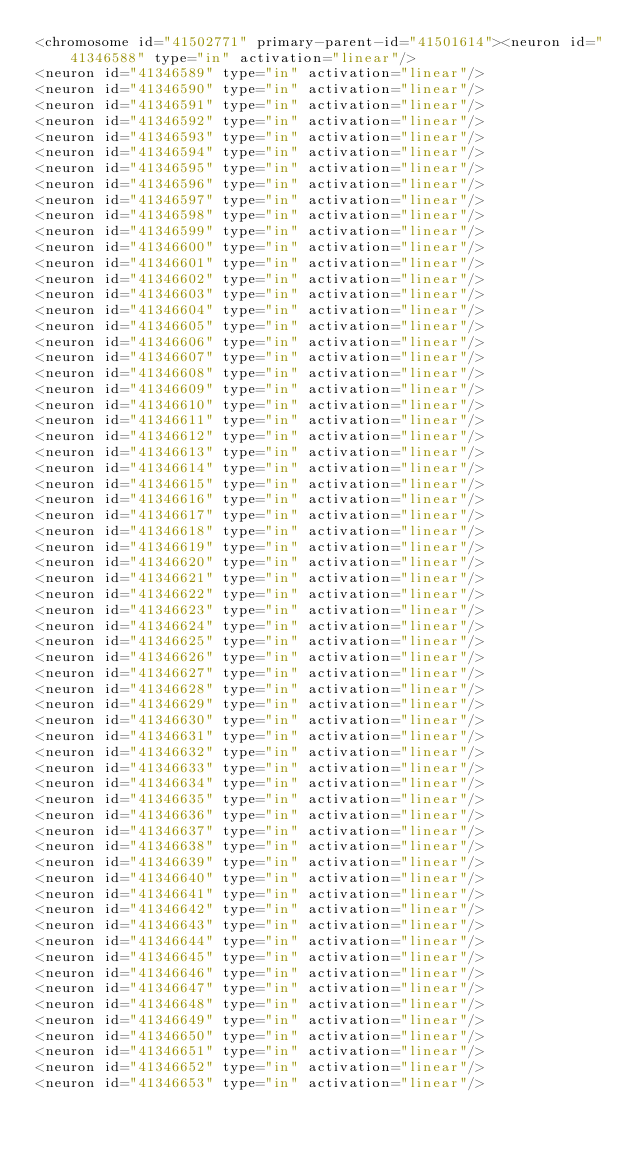<code> <loc_0><loc_0><loc_500><loc_500><_XML_><chromosome id="41502771" primary-parent-id="41501614"><neuron id="41346588" type="in" activation="linear"/>
<neuron id="41346589" type="in" activation="linear"/>
<neuron id="41346590" type="in" activation="linear"/>
<neuron id="41346591" type="in" activation="linear"/>
<neuron id="41346592" type="in" activation="linear"/>
<neuron id="41346593" type="in" activation="linear"/>
<neuron id="41346594" type="in" activation="linear"/>
<neuron id="41346595" type="in" activation="linear"/>
<neuron id="41346596" type="in" activation="linear"/>
<neuron id="41346597" type="in" activation="linear"/>
<neuron id="41346598" type="in" activation="linear"/>
<neuron id="41346599" type="in" activation="linear"/>
<neuron id="41346600" type="in" activation="linear"/>
<neuron id="41346601" type="in" activation="linear"/>
<neuron id="41346602" type="in" activation="linear"/>
<neuron id="41346603" type="in" activation="linear"/>
<neuron id="41346604" type="in" activation="linear"/>
<neuron id="41346605" type="in" activation="linear"/>
<neuron id="41346606" type="in" activation="linear"/>
<neuron id="41346607" type="in" activation="linear"/>
<neuron id="41346608" type="in" activation="linear"/>
<neuron id="41346609" type="in" activation="linear"/>
<neuron id="41346610" type="in" activation="linear"/>
<neuron id="41346611" type="in" activation="linear"/>
<neuron id="41346612" type="in" activation="linear"/>
<neuron id="41346613" type="in" activation="linear"/>
<neuron id="41346614" type="in" activation="linear"/>
<neuron id="41346615" type="in" activation="linear"/>
<neuron id="41346616" type="in" activation="linear"/>
<neuron id="41346617" type="in" activation="linear"/>
<neuron id="41346618" type="in" activation="linear"/>
<neuron id="41346619" type="in" activation="linear"/>
<neuron id="41346620" type="in" activation="linear"/>
<neuron id="41346621" type="in" activation="linear"/>
<neuron id="41346622" type="in" activation="linear"/>
<neuron id="41346623" type="in" activation="linear"/>
<neuron id="41346624" type="in" activation="linear"/>
<neuron id="41346625" type="in" activation="linear"/>
<neuron id="41346626" type="in" activation="linear"/>
<neuron id="41346627" type="in" activation="linear"/>
<neuron id="41346628" type="in" activation="linear"/>
<neuron id="41346629" type="in" activation="linear"/>
<neuron id="41346630" type="in" activation="linear"/>
<neuron id="41346631" type="in" activation="linear"/>
<neuron id="41346632" type="in" activation="linear"/>
<neuron id="41346633" type="in" activation="linear"/>
<neuron id="41346634" type="in" activation="linear"/>
<neuron id="41346635" type="in" activation="linear"/>
<neuron id="41346636" type="in" activation="linear"/>
<neuron id="41346637" type="in" activation="linear"/>
<neuron id="41346638" type="in" activation="linear"/>
<neuron id="41346639" type="in" activation="linear"/>
<neuron id="41346640" type="in" activation="linear"/>
<neuron id="41346641" type="in" activation="linear"/>
<neuron id="41346642" type="in" activation="linear"/>
<neuron id="41346643" type="in" activation="linear"/>
<neuron id="41346644" type="in" activation="linear"/>
<neuron id="41346645" type="in" activation="linear"/>
<neuron id="41346646" type="in" activation="linear"/>
<neuron id="41346647" type="in" activation="linear"/>
<neuron id="41346648" type="in" activation="linear"/>
<neuron id="41346649" type="in" activation="linear"/>
<neuron id="41346650" type="in" activation="linear"/>
<neuron id="41346651" type="in" activation="linear"/>
<neuron id="41346652" type="in" activation="linear"/>
<neuron id="41346653" type="in" activation="linear"/></code> 